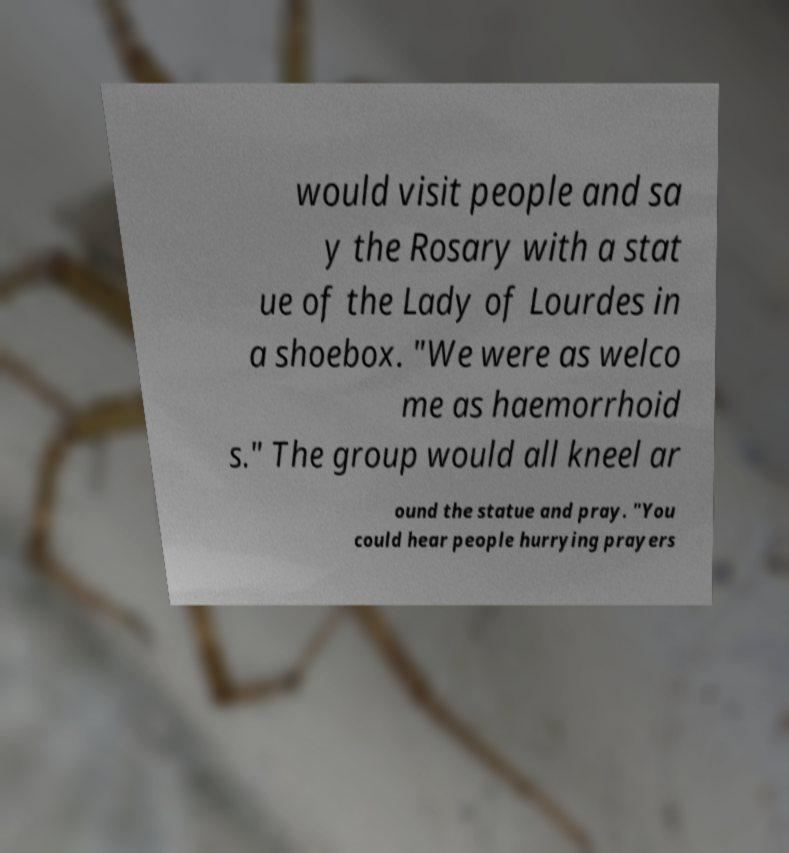Could you assist in decoding the text presented in this image and type it out clearly? would visit people and sa y the Rosary with a stat ue of the Lady of Lourdes in a shoebox. "We were as welco me as haemorrhoid s." The group would all kneel ar ound the statue and pray. "You could hear people hurrying prayers 